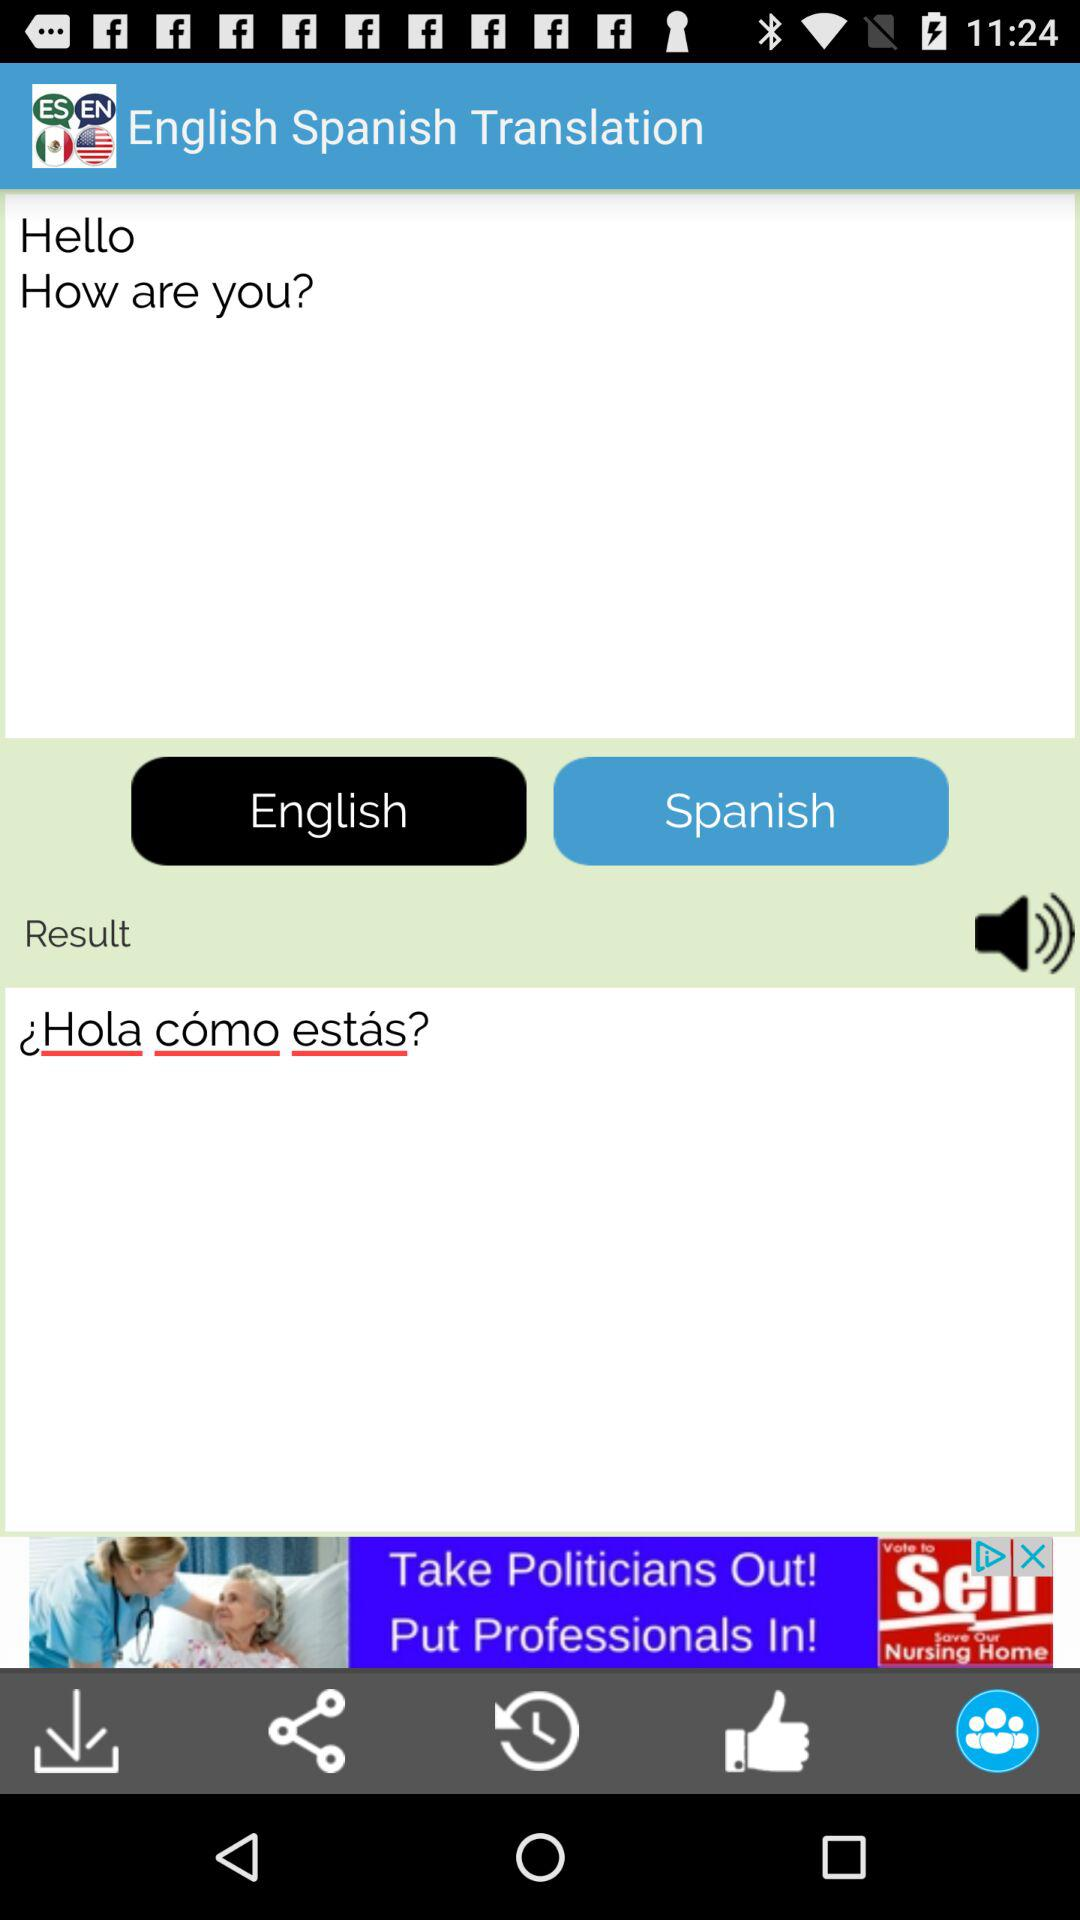What is the application name? The application name is "English Mexico Translator". 